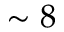<formula> <loc_0><loc_0><loc_500><loc_500>\sim 8</formula> 